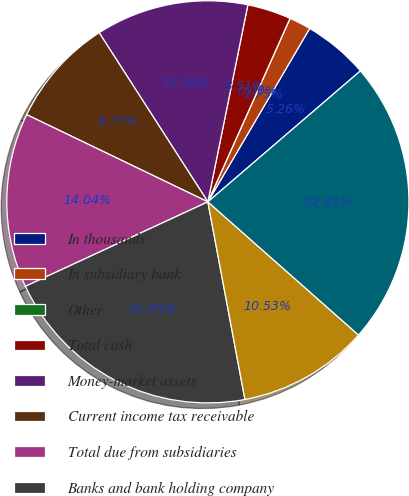Convert chart to OTSL. <chart><loc_0><loc_0><loc_500><loc_500><pie_chart><fcel>In thousands<fcel>In subsidiary bank<fcel>Other<fcel>Total cash<fcel>Money-market assets<fcel>Current income tax receivable<fcel>Total due from subsidiaries<fcel>Banks and bank holding company<fcel>Other assets<fcel>Total assets<nl><fcel>5.26%<fcel>1.75%<fcel>0.0%<fcel>3.51%<fcel>12.28%<fcel>8.77%<fcel>14.04%<fcel>21.05%<fcel>10.53%<fcel>22.81%<nl></chart> 